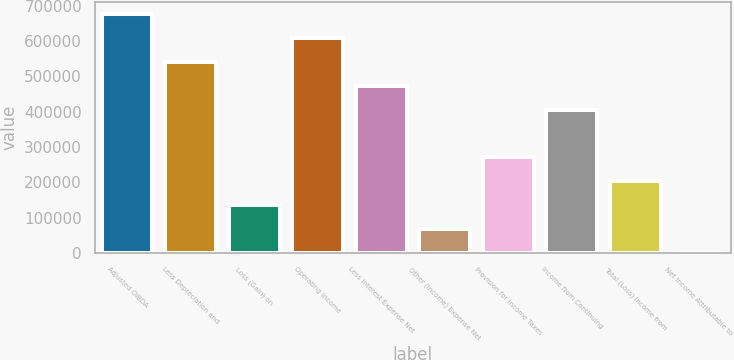Convert chart. <chart><loc_0><loc_0><loc_500><loc_500><bar_chart><fcel>Adjusted OIBDA<fcel>Less Depreciation and<fcel>Loss (Gain) on<fcel>Operating Income<fcel>Less Interest Expense Net<fcel>Other (Income) Expense Net<fcel>Provision for Income Taxes<fcel>Income from Continuing<fcel>Total (Loss) Income from<fcel>Net Income Attributable to<nl><fcel>676165<fcel>541116<fcel>135969<fcel>608640<fcel>473592<fcel>68444.5<fcel>271018<fcel>406067<fcel>203494<fcel>920<nl></chart> 